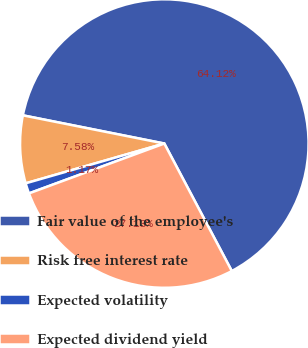Convert chart to OTSL. <chart><loc_0><loc_0><loc_500><loc_500><pie_chart><fcel>Fair value of the employee's<fcel>Risk free interest rate<fcel>Expected volatility<fcel>Expected dividend yield<nl><fcel>64.12%<fcel>7.58%<fcel>1.17%<fcel>27.13%<nl></chart> 